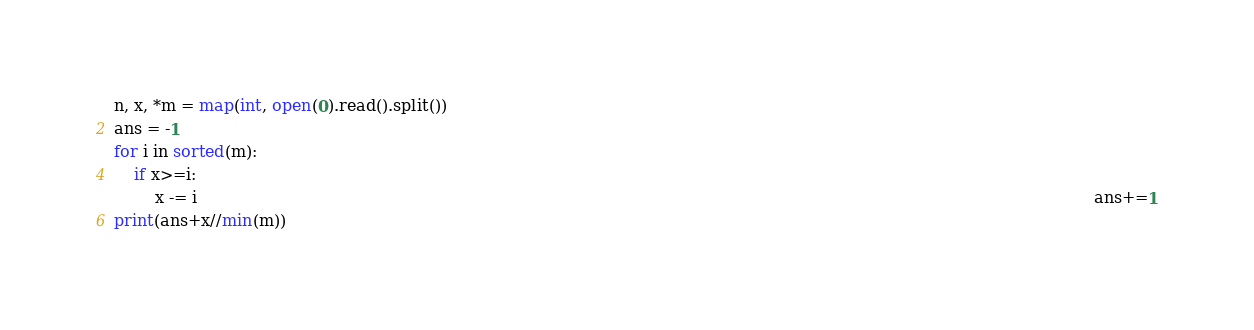<code> <loc_0><loc_0><loc_500><loc_500><_Python_>n, x, *m = map(int, open(0).read().split())
ans = -1
for i in sorted(m):
    if x>=i:
        x -= i                                                                                                                                                                                ans+=1
print(ans+x//min(m))</code> 